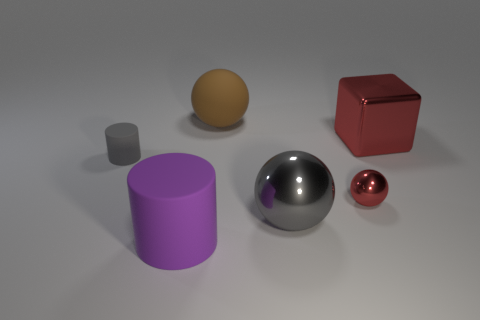Subtract all small metallic spheres. How many spheres are left? 2 Add 1 big purple shiny spheres. How many objects exist? 7 Subtract all cylinders. How many objects are left? 4 Subtract 1 spheres. How many spheres are left? 2 Subtract all rubber balls. Subtract all gray objects. How many objects are left? 3 Add 4 tiny objects. How many tiny objects are left? 6 Add 5 gray metallic balls. How many gray metallic balls exist? 6 Subtract 0 cyan blocks. How many objects are left? 6 Subtract all yellow cylinders. Subtract all purple blocks. How many cylinders are left? 2 